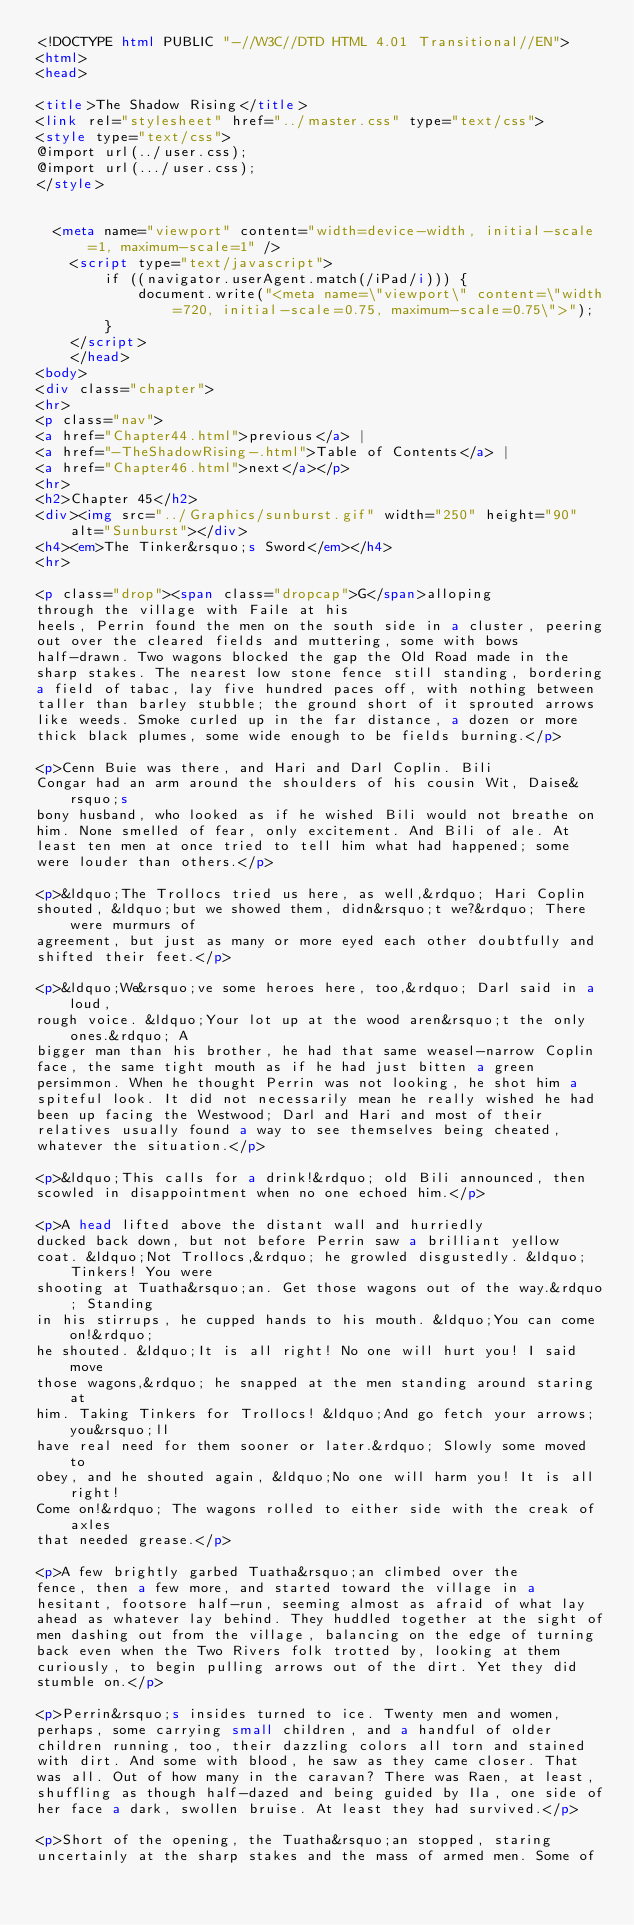<code> <loc_0><loc_0><loc_500><loc_500><_HTML_><!DOCTYPE html PUBLIC "-//W3C//DTD HTML 4.01 Transitional//EN">
<html>
<head>

<title>The Shadow Rising</title>
<link rel="stylesheet" href="../master.css" type="text/css">
<style type="text/css">
@import url(../user.css);
@import url(.../user.css);
</style>


	<meta name="viewport" content="width=device-width, initial-scale=1, maximum-scale=1" />
    <script type="text/javascript">
        if ((navigator.userAgent.match(/iPad/i))) {
            document.write("<meta name=\"viewport\" content=\"width=720, initial-scale=0.75, maximum-scale=0.75\">");
        }
    </script>
    </head>
<body>
<div class="chapter">
<hr>
<p class="nav">
<a href="Chapter44.html">previous</a> |
<a href="-TheShadowRising-.html">Table of Contents</a> |
<a href="Chapter46.html">next</a></p>
<hr>
<h2>Chapter 45</h2>
<div><img src="../Graphics/sunburst.gif" width="250" height="90" alt="Sunburst"></div>
<h4><em>The Tinker&rsquo;s Sword</em></h4>
<hr>

<p class="drop"><span class="dropcap">G</span>alloping
through the village with Faile at his
heels, Perrin found the men on the south side in a cluster, peering
out over the cleared fields and muttering, some with bows
half-drawn. Two wagons blocked the gap the Old Road made in the
sharp stakes. The nearest low stone fence still standing, bordering
a field of tabac, lay five hundred paces off, with nothing between
taller than barley stubble; the ground short of it sprouted arrows
like weeds. Smoke curled up in the far distance, a dozen or more
thick black plumes, some wide enough to be fields burning.</p>

<p>Cenn Buie was there, and Hari and Darl Coplin. Bili
Congar had an arm around the shoulders of his cousin Wit, Daise&rsquo;s
bony husband, who looked as if he wished Bili would not breathe on
him. None smelled of fear, only excitement. And Bili of ale. At
least ten men at once tried to tell him what had happened; some
were louder than others.</p>

<p>&ldquo;The Trollocs tried us here, as well,&rdquo; Hari Coplin
shouted, &ldquo;but we showed them, didn&rsquo;t we?&rdquo; There were murmurs of
agreement, but just as many or more eyed each other doubtfully and
shifted their feet.</p>

<p>&ldquo;We&rsquo;ve some heroes here, too,&rdquo; Darl said in a loud,
rough voice. &ldquo;Your lot up at the wood aren&rsquo;t the only ones.&rdquo; A
bigger man than his brother, he had that same weasel-narrow Coplin
face, the same tight mouth as if he had just bitten a green
persimmon. When he thought Perrin was not looking, he shot him a
spiteful look. It did not necessarily mean he really wished he had
been up facing the Westwood; Darl and Hari and most of their
relatives usually found a way to see themselves being cheated,
whatever the situation.</p>

<p>&ldquo;This calls for a drink!&rdquo; old Bili announced, then
scowled in disappointment when no one echoed him.</p>

<p>A head lifted above the distant wall and hurriedly
ducked back down, but not before Perrin saw a brilliant yellow
coat. &ldquo;Not Trollocs,&rdquo; he growled disgustedly. &ldquo;Tinkers! You were
shooting at Tuatha&rsquo;an. Get those wagons out of the way.&rdquo; Standing
in his stirrups, he cupped hands to his mouth. &ldquo;You can come on!&rdquo;
he shouted. &ldquo;It is all right! No one will hurt you! I said move
those wagons,&rdquo; he snapped at the men standing around staring at
him. Taking Tinkers for Trollocs! &ldquo;And go fetch your arrows; you&rsquo;ll
have real need for them sooner or later.&rdquo; Slowly some moved to
obey, and he shouted again, &ldquo;No one will harm you! It is all right!
Come on!&rdquo; The wagons rolled to either side with the creak of axles
that needed grease.</p>

<p>A few brightly garbed Tuatha&rsquo;an climbed over the
fence, then a few more, and started toward the village in a
hesitant, footsore half-run, seeming almost as afraid of what lay
ahead as whatever lay behind. They huddled together at the sight of
men dashing out from the village, balancing on the edge of turning
back even when the Two Rivers folk trotted by, looking at them
curiously, to begin pulling arrows out of the dirt. Yet they did
stumble on.</p>

<p>Perrin&rsquo;s insides turned to ice. Twenty men and women,
perhaps, some carrying small children, and a handful of older
children running, too, their dazzling colors all torn and stained
with dirt. And some with blood, he saw as they came closer. That
was all. Out of how many in the caravan? There was Raen, at least,
shuffling as though half-dazed and being guided by Ila, one side of
her face a dark, swollen bruise. At least they had survived.</p>

<p>Short of the opening, the Tuatha&rsquo;an stopped, staring
uncertainly at the sharp stakes and the mass of armed men. Some of</code> 